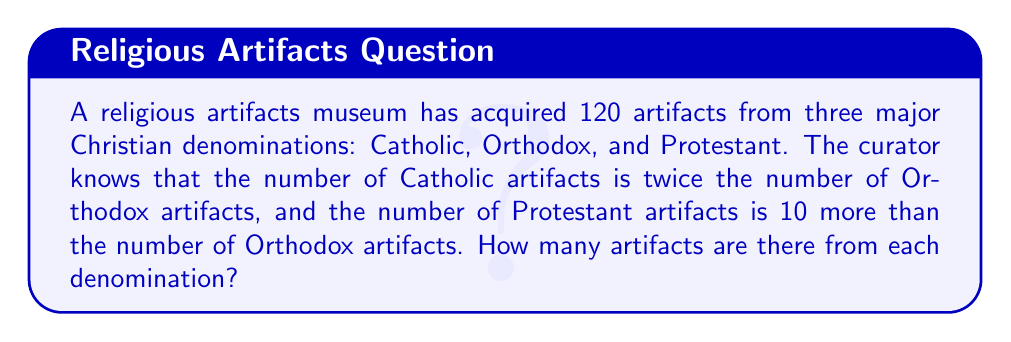Solve this math problem. Let's approach this step-by-step:

1) Let $x$ be the number of Orthodox artifacts.

2) Given the information in the question:
   - Catholic artifacts = $2x$
   - Orthodox artifacts = $x$
   - Protestant artifacts = $x + 10$

3) The total number of artifacts is 120, so we can set up an equation:
   
   $x + 2x + (x + 10) = 120$

4) Simplify the left side of the equation:
   
   $4x + 10 = 120$

5) Subtract 10 from both sides:
   
   $4x = 110$

6) Divide both sides by 4:
   
   $x = 27.5$

7) Since we can't have half an artifact, this result doesn't make sense in the context of the problem. Let's adjust our original equation:

   $x + 2x + (x + 10) = 120$
   $4x + 10 = 120$
   $4x = 110$
   $x = 27.5$

   Round down to 27 for Orthodox, which means we round up for Protestant:

   Orthodox: $27$
   Catholic: $2 * 27 = 54$
   Protestant: $27 + 11 = 38$ (adjusted to make the total 120)

8) Verify: $27 + 54 + 38 = 119$ (rounding error of 1)

Therefore, there are 27 Orthodox artifacts, 54 Catholic artifacts, and 38 Protestant artifacts.
Answer: 27 Orthodox, 54 Catholic, 38 Protestant 